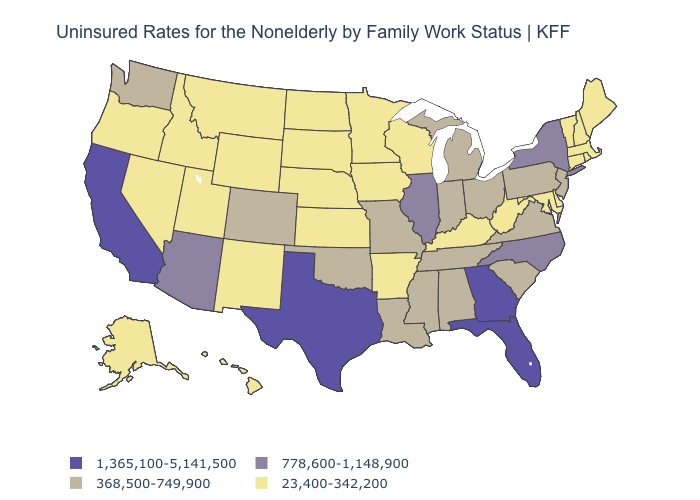What is the value of Alabama?
Concise answer only. 368,500-749,900. What is the value of South Carolina?
Answer briefly. 368,500-749,900. What is the highest value in states that border Vermont?
Write a very short answer. 778,600-1,148,900. What is the value of Wyoming?
Keep it brief. 23,400-342,200. Which states hav the highest value in the South?
Quick response, please. Florida, Georgia, Texas. Which states have the highest value in the USA?
Give a very brief answer. California, Florida, Georgia, Texas. What is the highest value in states that border Wisconsin?
Answer briefly. 778,600-1,148,900. Name the states that have a value in the range 23,400-342,200?
Keep it brief. Alaska, Arkansas, Connecticut, Delaware, Hawaii, Idaho, Iowa, Kansas, Kentucky, Maine, Maryland, Massachusetts, Minnesota, Montana, Nebraska, Nevada, New Hampshire, New Mexico, North Dakota, Oregon, Rhode Island, South Dakota, Utah, Vermont, West Virginia, Wisconsin, Wyoming. Which states have the highest value in the USA?
Quick response, please. California, Florida, Georgia, Texas. What is the lowest value in states that border Ohio?
Short answer required. 23,400-342,200. Does New York have the highest value in the Northeast?
Write a very short answer. Yes. What is the value of West Virginia?
Short answer required. 23,400-342,200. What is the lowest value in the USA?
Short answer required. 23,400-342,200. Which states hav the highest value in the MidWest?
Write a very short answer. Illinois. 